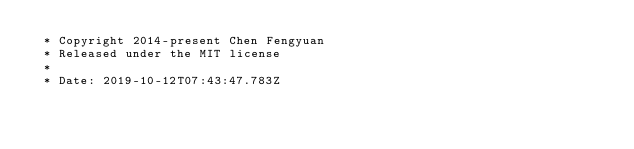Convert code to text. <code><loc_0><loc_0><loc_500><loc_500><_CSS_> * Copyright 2014-present Chen Fengyuan
 * Released under the MIT license
 *
 * Date: 2019-10-12T07:43:47.783Z</code> 